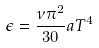<formula> <loc_0><loc_0><loc_500><loc_500>\epsilon = \frac { \nu \pi ^ { 2 } } { 3 0 } a T ^ { 4 } \,</formula> 